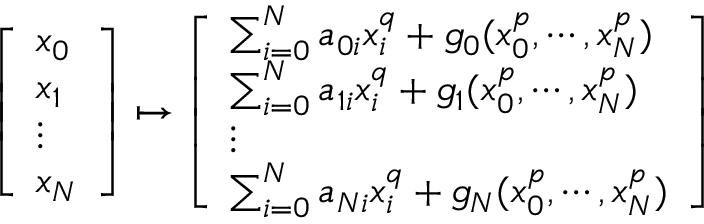Convert formula to latex. <formula><loc_0><loc_0><loc_500><loc_500>\left [ \begin{array} { l } { x _ { 0 } } \\ { x _ { 1 } } \\ { \vdots } \\ { x _ { N } } \end{array} \right ] \mapsto \left [ \begin{array} { l } { \sum _ { i = 0 } ^ { N } a _ { 0 i } x _ { i } ^ { q } + g _ { 0 } ( x _ { 0 } ^ { p } , \cdots , x _ { N } ^ { p } ) } \\ { \sum _ { i = 0 } ^ { N } a _ { 1 i } x _ { i } ^ { q } + g _ { 1 } ( x _ { 0 } ^ { p } , \cdots , x _ { N } ^ { p } ) } \\ { \vdots } \\ { \sum _ { i = 0 } ^ { N } a _ { N i } x _ { i } ^ { q } + g _ { N } ( x _ { 0 } ^ { p } , \cdots , x _ { N } ^ { p } ) } \end{array} \right ]</formula> 